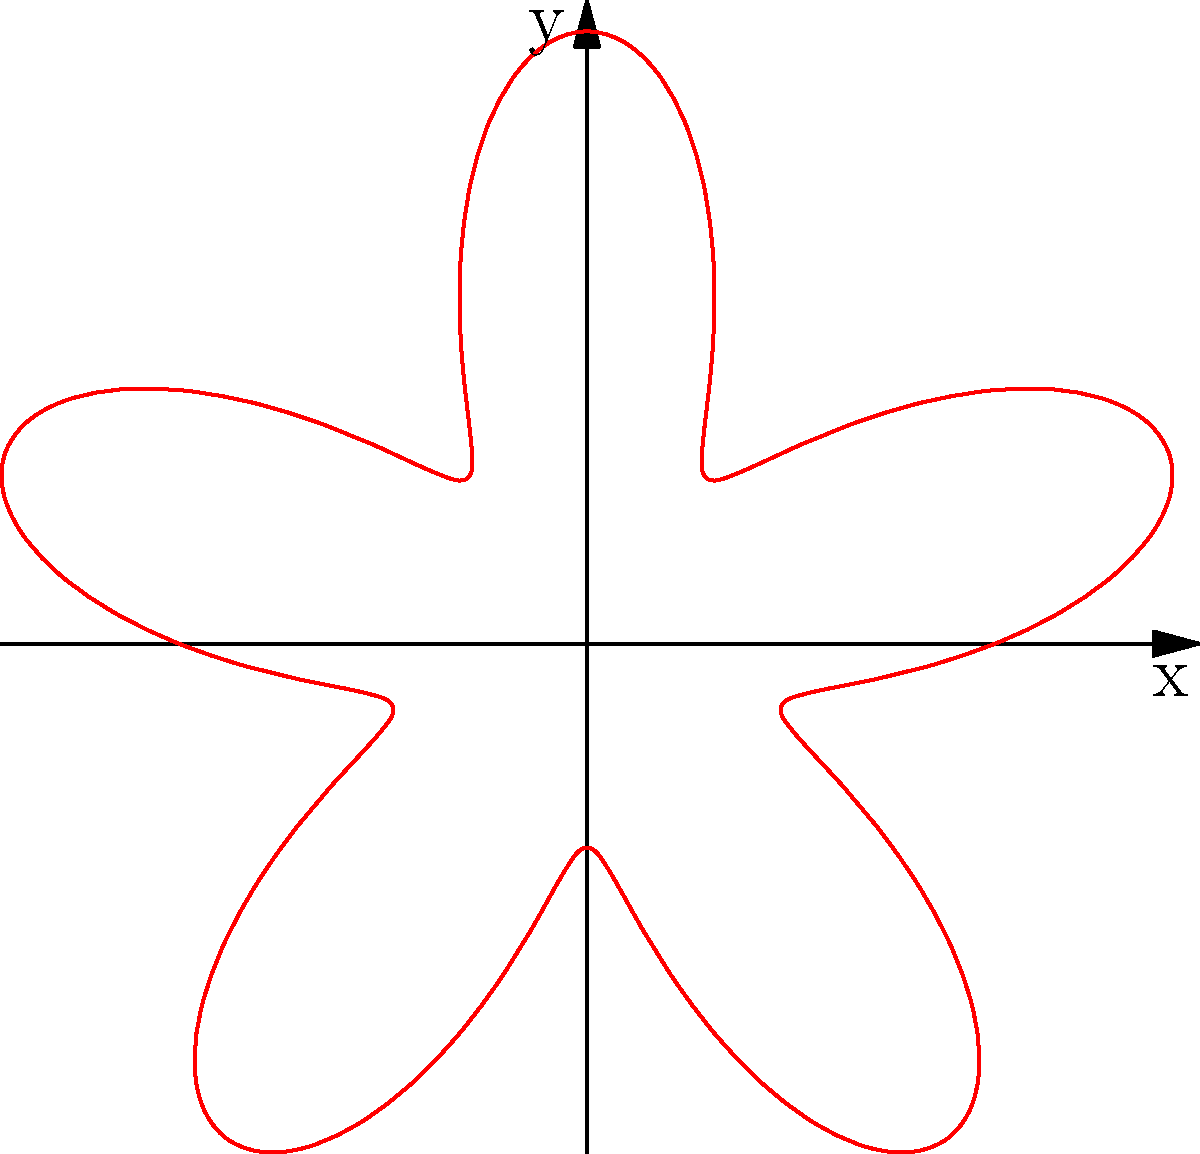As a photography enthusiast capturing the Vatican's masterpieces, you're fascinated by the spiral pattern of a rose window. The pattern can be described in polar coordinates by the equation $r = 2 + \sin(5\theta)$. What is the maximum radial distance from the center of the window to the outermost point of the spiral? To find the maximum radial distance, we need to follow these steps:

1) The equation given is $r = 2 + \sin(5\theta)$

2) The maximum value will occur when $\sin(5\theta)$ is at its maximum, which is 1.

3) Therefore, the maximum radial distance will be:

   $r_{max} = 2 + 1 = 3$

4) This means that the furthest point of the spiral from the center is at a distance of 3 units.

5) We can verify this by looking at the graph, where we see that the spiral extends to a maximum of 3 units from the origin.
Answer: 3 units 